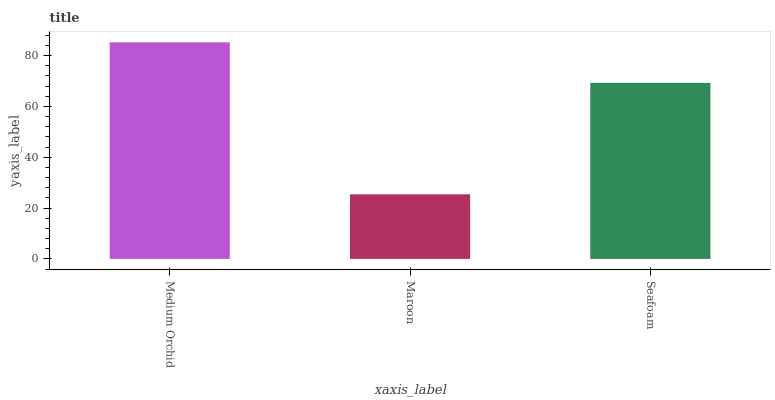Is Maroon the minimum?
Answer yes or no. Yes. Is Medium Orchid the maximum?
Answer yes or no. Yes. Is Seafoam the minimum?
Answer yes or no. No. Is Seafoam the maximum?
Answer yes or no. No. Is Seafoam greater than Maroon?
Answer yes or no. Yes. Is Maroon less than Seafoam?
Answer yes or no. Yes. Is Maroon greater than Seafoam?
Answer yes or no. No. Is Seafoam less than Maroon?
Answer yes or no. No. Is Seafoam the high median?
Answer yes or no. Yes. Is Seafoam the low median?
Answer yes or no. Yes. Is Medium Orchid the high median?
Answer yes or no. No. Is Medium Orchid the low median?
Answer yes or no. No. 